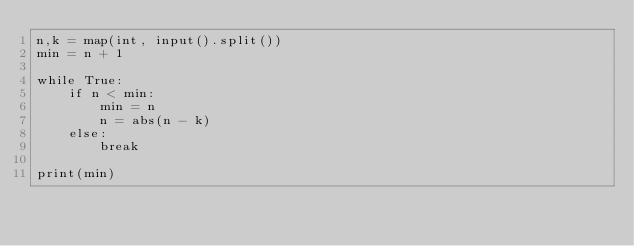Convert code to text. <code><loc_0><loc_0><loc_500><loc_500><_Python_>n,k = map(int, input().split())
min = n + 1

while True:
    if n < min:
        min = n
        n = abs(n - k)
    else:
        break

print(min)
</code> 